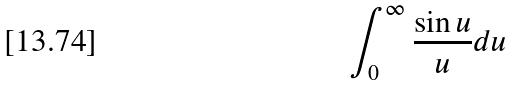Convert formula to latex. <formula><loc_0><loc_0><loc_500><loc_500>\int _ { 0 } ^ { \infty } \frac { \sin u } { u } d u</formula> 